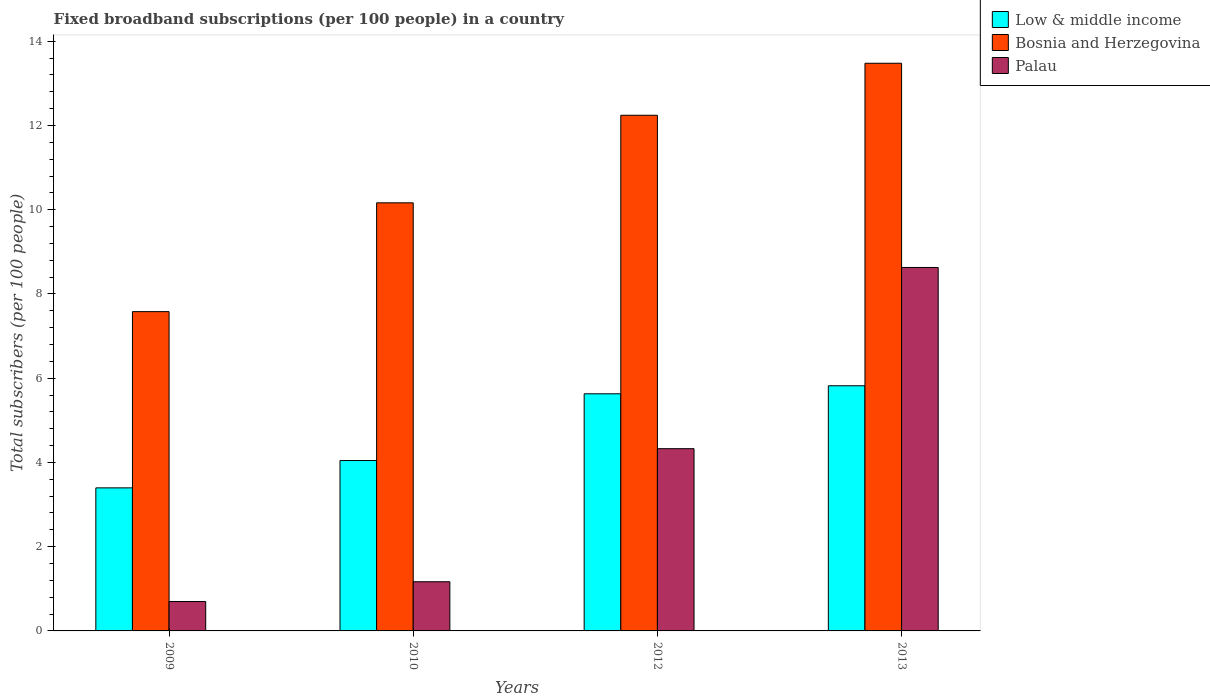Are the number of bars per tick equal to the number of legend labels?
Offer a very short reply. Yes. Are the number of bars on each tick of the X-axis equal?
Offer a very short reply. Yes. How many bars are there on the 3rd tick from the right?
Provide a short and direct response. 3. What is the label of the 2nd group of bars from the left?
Offer a terse response. 2010. In how many cases, is the number of bars for a given year not equal to the number of legend labels?
Your answer should be very brief. 0. What is the number of broadband subscriptions in Bosnia and Herzegovina in 2012?
Your answer should be compact. 12.24. Across all years, what is the maximum number of broadband subscriptions in Low & middle income?
Offer a very short reply. 5.82. Across all years, what is the minimum number of broadband subscriptions in Bosnia and Herzegovina?
Provide a succinct answer. 7.58. What is the total number of broadband subscriptions in Bosnia and Herzegovina in the graph?
Provide a short and direct response. 43.47. What is the difference between the number of broadband subscriptions in Bosnia and Herzegovina in 2009 and that in 2013?
Make the answer very short. -5.9. What is the difference between the number of broadband subscriptions in Palau in 2010 and the number of broadband subscriptions in Low & middle income in 2009?
Provide a succinct answer. -2.23. What is the average number of broadband subscriptions in Low & middle income per year?
Make the answer very short. 4.72. In the year 2012, what is the difference between the number of broadband subscriptions in Bosnia and Herzegovina and number of broadband subscriptions in Palau?
Provide a succinct answer. 7.92. What is the ratio of the number of broadband subscriptions in Bosnia and Herzegovina in 2009 to that in 2012?
Your response must be concise. 0.62. Is the number of broadband subscriptions in Bosnia and Herzegovina in 2010 less than that in 2012?
Make the answer very short. Yes. Is the difference between the number of broadband subscriptions in Bosnia and Herzegovina in 2009 and 2012 greater than the difference between the number of broadband subscriptions in Palau in 2009 and 2012?
Offer a terse response. No. What is the difference between the highest and the second highest number of broadband subscriptions in Low & middle income?
Give a very brief answer. 0.19. What is the difference between the highest and the lowest number of broadband subscriptions in Palau?
Provide a short and direct response. 7.93. In how many years, is the number of broadband subscriptions in Low & middle income greater than the average number of broadband subscriptions in Low & middle income taken over all years?
Your answer should be very brief. 2. Is the sum of the number of broadband subscriptions in Low & middle income in 2009 and 2012 greater than the maximum number of broadband subscriptions in Palau across all years?
Give a very brief answer. Yes. What does the 2nd bar from the left in 2009 represents?
Provide a succinct answer. Bosnia and Herzegovina. What does the 2nd bar from the right in 2010 represents?
Your answer should be very brief. Bosnia and Herzegovina. How many years are there in the graph?
Your response must be concise. 4. Does the graph contain any zero values?
Your response must be concise. No. Does the graph contain grids?
Your answer should be compact. No. Where does the legend appear in the graph?
Provide a succinct answer. Top right. How many legend labels are there?
Your answer should be very brief. 3. What is the title of the graph?
Ensure brevity in your answer.  Fixed broadband subscriptions (per 100 people) in a country. What is the label or title of the X-axis?
Ensure brevity in your answer.  Years. What is the label or title of the Y-axis?
Provide a succinct answer. Total subscribers (per 100 people). What is the Total subscribers (per 100 people) in Low & middle income in 2009?
Make the answer very short. 3.4. What is the Total subscribers (per 100 people) of Bosnia and Herzegovina in 2009?
Offer a terse response. 7.58. What is the Total subscribers (per 100 people) of Palau in 2009?
Offer a very short reply. 0.7. What is the Total subscribers (per 100 people) in Low & middle income in 2010?
Your answer should be very brief. 4.05. What is the Total subscribers (per 100 people) in Bosnia and Herzegovina in 2010?
Offer a terse response. 10.16. What is the Total subscribers (per 100 people) in Palau in 2010?
Your answer should be very brief. 1.17. What is the Total subscribers (per 100 people) in Low & middle income in 2012?
Provide a succinct answer. 5.63. What is the Total subscribers (per 100 people) in Bosnia and Herzegovina in 2012?
Ensure brevity in your answer.  12.24. What is the Total subscribers (per 100 people) in Palau in 2012?
Your response must be concise. 4.33. What is the Total subscribers (per 100 people) in Low & middle income in 2013?
Offer a terse response. 5.82. What is the Total subscribers (per 100 people) of Bosnia and Herzegovina in 2013?
Your response must be concise. 13.48. What is the Total subscribers (per 100 people) in Palau in 2013?
Provide a short and direct response. 8.63. Across all years, what is the maximum Total subscribers (per 100 people) of Low & middle income?
Offer a terse response. 5.82. Across all years, what is the maximum Total subscribers (per 100 people) of Bosnia and Herzegovina?
Your response must be concise. 13.48. Across all years, what is the maximum Total subscribers (per 100 people) in Palau?
Provide a succinct answer. 8.63. Across all years, what is the minimum Total subscribers (per 100 people) in Low & middle income?
Keep it short and to the point. 3.4. Across all years, what is the minimum Total subscribers (per 100 people) of Bosnia and Herzegovina?
Make the answer very short. 7.58. Across all years, what is the minimum Total subscribers (per 100 people) in Palau?
Give a very brief answer. 0.7. What is the total Total subscribers (per 100 people) in Low & middle income in the graph?
Your answer should be very brief. 18.89. What is the total Total subscribers (per 100 people) of Bosnia and Herzegovina in the graph?
Provide a succinct answer. 43.47. What is the total Total subscribers (per 100 people) in Palau in the graph?
Your answer should be very brief. 14.82. What is the difference between the Total subscribers (per 100 people) of Low & middle income in 2009 and that in 2010?
Provide a short and direct response. -0.65. What is the difference between the Total subscribers (per 100 people) of Bosnia and Herzegovina in 2009 and that in 2010?
Your answer should be compact. -2.58. What is the difference between the Total subscribers (per 100 people) of Palau in 2009 and that in 2010?
Offer a terse response. -0.47. What is the difference between the Total subscribers (per 100 people) in Low & middle income in 2009 and that in 2012?
Ensure brevity in your answer.  -2.23. What is the difference between the Total subscribers (per 100 people) of Bosnia and Herzegovina in 2009 and that in 2012?
Keep it short and to the point. -4.66. What is the difference between the Total subscribers (per 100 people) in Palau in 2009 and that in 2012?
Offer a very short reply. -3.63. What is the difference between the Total subscribers (per 100 people) of Low & middle income in 2009 and that in 2013?
Give a very brief answer. -2.42. What is the difference between the Total subscribers (per 100 people) in Bosnia and Herzegovina in 2009 and that in 2013?
Give a very brief answer. -5.9. What is the difference between the Total subscribers (per 100 people) of Palau in 2009 and that in 2013?
Your answer should be very brief. -7.93. What is the difference between the Total subscribers (per 100 people) of Low & middle income in 2010 and that in 2012?
Offer a terse response. -1.58. What is the difference between the Total subscribers (per 100 people) of Bosnia and Herzegovina in 2010 and that in 2012?
Your answer should be very brief. -2.08. What is the difference between the Total subscribers (per 100 people) of Palau in 2010 and that in 2012?
Provide a succinct answer. -3.16. What is the difference between the Total subscribers (per 100 people) of Low & middle income in 2010 and that in 2013?
Provide a succinct answer. -1.78. What is the difference between the Total subscribers (per 100 people) of Bosnia and Herzegovina in 2010 and that in 2013?
Provide a succinct answer. -3.31. What is the difference between the Total subscribers (per 100 people) in Palau in 2010 and that in 2013?
Offer a terse response. -7.46. What is the difference between the Total subscribers (per 100 people) in Low & middle income in 2012 and that in 2013?
Your answer should be compact. -0.19. What is the difference between the Total subscribers (per 100 people) in Bosnia and Herzegovina in 2012 and that in 2013?
Your response must be concise. -1.23. What is the difference between the Total subscribers (per 100 people) in Palau in 2012 and that in 2013?
Keep it short and to the point. -4.3. What is the difference between the Total subscribers (per 100 people) of Low & middle income in 2009 and the Total subscribers (per 100 people) of Bosnia and Herzegovina in 2010?
Your response must be concise. -6.77. What is the difference between the Total subscribers (per 100 people) in Low & middle income in 2009 and the Total subscribers (per 100 people) in Palau in 2010?
Provide a succinct answer. 2.23. What is the difference between the Total subscribers (per 100 people) in Bosnia and Herzegovina in 2009 and the Total subscribers (per 100 people) in Palau in 2010?
Ensure brevity in your answer.  6.41. What is the difference between the Total subscribers (per 100 people) of Low & middle income in 2009 and the Total subscribers (per 100 people) of Bosnia and Herzegovina in 2012?
Offer a very short reply. -8.85. What is the difference between the Total subscribers (per 100 people) of Low & middle income in 2009 and the Total subscribers (per 100 people) of Palau in 2012?
Provide a short and direct response. -0.93. What is the difference between the Total subscribers (per 100 people) in Bosnia and Herzegovina in 2009 and the Total subscribers (per 100 people) in Palau in 2012?
Your answer should be compact. 3.25. What is the difference between the Total subscribers (per 100 people) of Low & middle income in 2009 and the Total subscribers (per 100 people) of Bosnia and Herzegovina in 2013?
Offer a terse response. -10.08. What is the difference between the Total subscribers (per 100 people) in Low & middle income in 2009 and the Total subscribers (per 100 people) in Palau in 2013?
Make the answer very short. -5.23. What is the difference between the Total subscribers (per 100 people) in Bosnia and Herzegovina in 2009 and the Total subscribers (per 100 people) in Palau in 2013?
Your response must be concise. -1.05. What is the difference between the Total subscribers (per 100 people) in Low & middle income in 2010 and the Total subscribers (per 100 people) in Bosnia and Herzegovina in 2012?
Give a very brief answer. -8.2. What is the difference between the Total subscribers (per 100 people) in Low & middle income in 2010 and the Total subscribers (per 100 people) in Palau in 2012?
Keep it short and to the point. -0.28. What is the difference between the Total subscribers (per 100 people) of Bosnia and Herzegovina in 2010 and the Total subscribers (per 100 people) of Palau in 2012?
Give a very brief answer. 5.84. What is the difference between the Total subscribers (per 100 people) in Low & middle income in 2010 and the Total subscribers (per 100 people) in Bosnia and Herzegovina in 2013?
Your response must be concise. -9.43. What is the difference between the Total subscribers (per 100 people) of Low & middle income in 2010 and the Total subscribers (per 100 people) of Palau in 2013?
Offer a terse response. -4.58. What is the difference between the Total subscribers (per 100 people) of Bosnia and Herzegovina in 2010 and the Total subscribers (per 100 people) of Palau in 2013?
Give a very brief answer. 1.54. What is the difference between the Total subscribers (per 100 people) in Low & middle income in 2012 and the Total subscribers (per 100 people) in Bosnia and Herzegovina in 2013?
Your answer should be very brief. -7.85. What is the difference between the Total subscribers (per 100 people) in Low & middle income in 2012 and the Total subscribers (per 100 people) in Palau in 2013?
Make the answer very short. -3. What is the difference between the Total subscribers (per 100 people) in Bosnia and Herzegovina in 2012 and the Total subscribers (per 100 people) in Palau in 2013?
Ensure brevity in your answer.  3.61. What is the average Total subscribers (per 100 people) of Low & middle income per year?
Provide a succinct answer. 4.72. What is the average Total subscribers (per 100 people) in Bosnia and Herzegovina per year?
Your answer should be very brief. 10.87. What is the average Total subscribers (per 100 people) in Palau per year?
Ensure brevity in your answer.  3.71. In the year 2009, what is the difference between the Total subscribers (per 100 people) in Low & middle income and Total subscribers (per 100 people) in Bosnia and Herzegovina?
Ensure brevity in your answer.  -4.18. In the year 2009, what is the difference between the Total subscribers (per 100 people) of Low & middle income and Total subscribers (per 100 people) of Palau?
Your answer should be compact. 2.7. In the year 2009, what is the difference between the Total subscribers (per 100 people) in Bosnia and Herzegovina and Total subscribers (per 100 people) in Palau?
Make the answer very short. 6.88. In the year 2010, what is the difference between the Total subscribers (per 100 people) of Low & middle income and Total subscribers (per 100 people) of Bosnia and Herzegovina?
Offer a terse response. -6.12. In the year 2010, what is the difference between the Total subscribers (per 100 people) in Low & middle income and Total subscribers (per 100 people) in Palau?
Your answer should be compact. 2.88. In the year 2010, what is the difference between the Total subscribers (per 100 people) of Bosnia and Herzegovina and Total subscribers (per 100 people) of Palau?
Offer a very short reply. 9. In the year 2012, what is the difference between the Total subscribers (per 100 people) in Low & middle income and Total subscribers (per 100 people) in Bosnia and Herzegovina?
Offer a very short reply. -6.61. In the year 2012, what is the difference between the Total subscribers (per 100 people) in Low & middle income and Total subscribers (per 100 people) in Palau?
Offer a terse response. 1.3. In the year 2012, what is the difference between the Total subscribers (per 100 people) in Bosnia and Herzegovina and Total subscribers (per 100 people) in Palau?
Provide a short and direct response. 7.92. In the year 2013, what is the difference between the Total subscribers (per 100 people) in Low & middle income and Total subscribers (per 100 people) in Bosnia and Herzegovina?
Your answer should be compact. -7.66. In the year 2013, what is the difference between the Total subscribers (per 100 people) of Low & middle income and Total subscribers (per 100 people) of Palau?
Ensure brevity in your answer.  -2.81. In the year 2013, what is the difference between the Total subscribers (per 100 people) in Bosnia and Herzegovina and Total subscribers (per 100 people) in Palau?
Provide a succinct answer. 4.85. What is the ratio of the Total subscribers (per 100 people) of Low & middle income in 2009 to that in 2010?
Provide a succinct answer. 0.84. What is the ratio of the Total subscribers (per 100 people) of Bosnia and Herzegovina in 2009 to that in 2010?
Offer a terse response. 0.75. What is the ratio of the Total subscribers (per 100 people) of Palau in 2009 to that in 2010?
Make the answer very short. 0.6. What is the ratio of the Total subscribers (per 100 people) of Low & middle income in 2009 to that in 2012?
Your answer should be compact. 0.6. What is the ratio of the Total subscribers (per 100 people) in Bosnia and Herzegovina in 2009 to that in 2012?
Your answer should be very brief. 0.62. What is the ratio of the Total subscribers (per 100 people) in Palau in 2009 to that in 2012?
Offer a very short reply. 0.16. What is the ratio of the Total subscribers (per 100 people) in Low & middle income in 2009 to that in 2013?
Make the answer very short. 0.58. What is the ratio of the Total subscribers (per 100 people) in Bosnia and Herzegovina in 2009 to that in 2013?
Your answer should be very brief. 0.56. What is the ratio of the Total subscribers (per 100 people) of Palau in 2009 to that in 2013?
Keep it short and to the point. 0.08. What is the ratio of the Total subscribers (per 100 people) in Low & middle income in 2010 to that in 2012?
Give a very brief answer. 0.72. What is the ratio of the Total subscribers (per 100 people) in Bosnia and Herzegovina in 2010 to that in 2012?
Ensure brevity in your answer.  0.83. What is the ratio of the Total subscribers (per 100 people) of Palau in 2010 to that in 2012?
Your answer should be very brief. 0.27. What is the ratio of the Total subscribers (per 100 people) of Low & middle income in 2010 to that in 2013?
Offer a terse response. 0.69. What is the ratio of the Total subscribers (per 100 people) of Bosnia and Herzegovina in 2010 to that in 2013?
Provide a succinct answer. 0.75. What is the ratio of the Total subscribers (per 100 people) of Palau in 2010 to that in 2013?
Make the answer very short. 0.14. What is the ratio of the Total subscribers (per 100 people) of Low & middle income in 2012 to that in 2013?
Your answer should be compact. 0.97. What is the ratio of the Total subscribers (per 100 people) of Bosnia and Herzegovina in 2012 to that in 2013?
Your answer should be compact. 0.91. What is the ratio of the Total subscribers (per 100 people) of Palau in 2012 to that in 2013?
Your response must be concise. 0.5. What is the difference between the highest and the second highest Total subscribers (per 100 people) in Low & middle income?
Your answer should be very brief. 0.19. What is the difference between the highest and the second highest Total subscribers (per 100 people) in Bosnia and Herzegovina?
Your response must be concise. 1.23. What is the difference between the highest and the second highest Total subscribers (per 100 people) in Palau?
Provide a succinct answer. 4.3. What is the difference between the highest and the lowest Total subscribers (per 100 people) of Low & middle income?
Your answer should be compact. 2.42. What is the difference between the highest and the lowest Total subscribers (per 100 people) of Bosnia and Herzegovina?
Make the answer very short. 5.9. What is the difference between the highest and the lowest Total subscribers (per 100 people) in Palau?
Your answer should be compact. 7.93. 